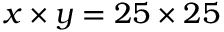Convert formula to latex. <formula><loc_0><loc_0><loc_500><loc_500>x \times y = 2 5 \times 2 5</formula> 